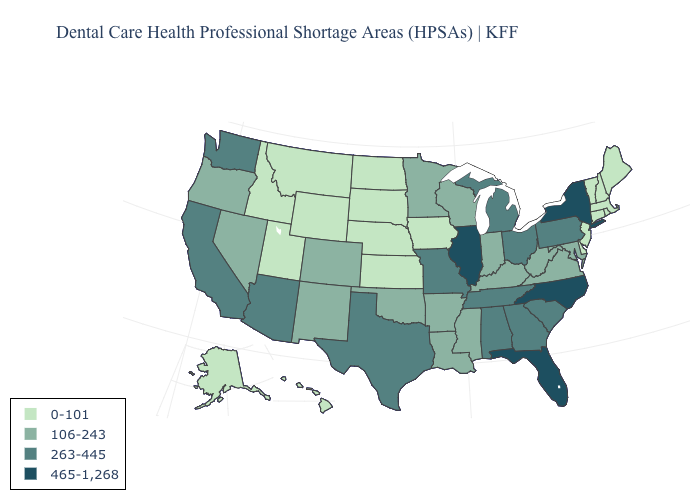Name the states that have a value in the range 106-243?
Write a very short answer. Arkansas, Colorado, Indiana, Kentucky, Louisiana, Maryland, Minnesota, Mississippi, Nevada, New Mexico, Oklahoma, Oregon, Virginia, West Virginia, Wisconsin. What is the value of Virginia?
Write a very short answer. 106-243. Does Louisiana have a lower value than North Carolina?
Be succinct. Yes. Among the states that border Delaware , which have the highest value?
Answer briefly. Pennsylvania. Does Idaho have the same value as Nebraska?
Short answer required. Yes. What is the highest value in the MidWest ?
Quick response, please. 465-1,268. What is the value of Kansas?
Concise answer only. 0-101. Name the states that have a value in the range 465-1,268?
Quick response, please. Florida, Illinois, New York, North Carolina. What is the highest value in the USA?
Keep it brief. 465-1,268. Name the states that have a value in the range 0-101?
Be succinct. Alaska, Connecticut, Delaware, Hawaii, Idaho, Iowa, Kansas, Maine, Massachusetts, Montana, Nebraska, New Hampshire, New Jersey, North Dakota, Rhode Island, South Dakota, Utah, Vermont, Wyoming. Name the states that have a value in the range 465-1,268?
Short answer required. Florida, Illinois, New York, North Carolina. Is the legend a continuous bar?
Answer briefly. No. Does the first symbol in the legend represent the smallest category?
Be succinct. Yes. Does Illinois have the highest value in the MidWest?
Answer briefly. Yes. 